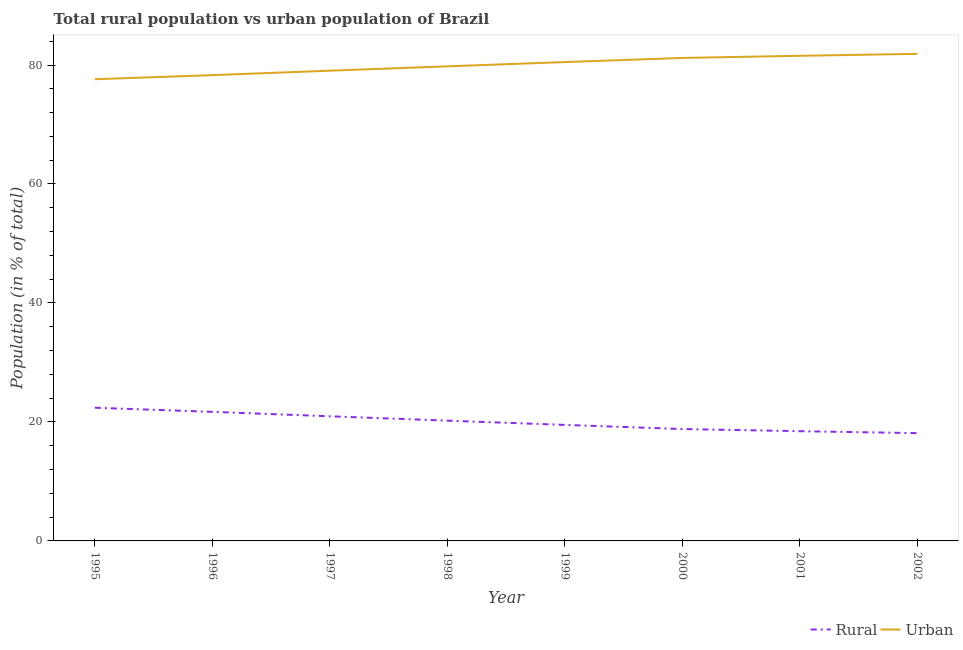What is the urban population in 1997?
Provide a short and direct response. 79.05. Across all years, what is the maximum urban population?
Make the answer very short. 81.88. Across all years, what is the minimum urban population?
Provide a short and direct response. 77.61. In which year was the rural population maximum?
Ensure brevity in your answer.  1995. What is the total rural population in the graph?
Keep it short and to the point. 160.14. What is the difference between the urban population in 1998 and that in 1999?
Your answer should be very brief. -0.72. What is the difference between the urban population in 1997 and the rural population in 1995?
Your response must be concise. 56.66. What is the average rural population per year?
Your response must be concise. 20.02. In the year 1995, what is the difference between the urban population and rural population?
Provide a short and direct response. 55.22. In how many years, is the rural population greater than 4 %?
Ensure brevity in your answer.  8. What is the ratio of the rural population in 1999 to that in 2002?
Your answer should be compact. 1.08. What is the difference between the highest and the second highest urban population?
Provide a short and direct response. 0.33. What is the difference between the highest and the lowest urban population?
Give a very brief answer. 4.27. In how many years, is the rural population greater than the average rural population taken over all years?
Your answer should be compact. 4. Does the urban population monotonically increase over the years?
Provide a succinct answer. Yes. Is the urban population strictly greater than the rural population over the years?
Provide a succinct answer. Yes. What is the difference between two consecutive major ticks on the Y-axis?
Give a very brief answer. 20. Are the values on the major ticks of Y-axis written in scientific E-notation?
Provide a short and direct response. No. How many legend labels are there?
Offer a very short reply. 2. How are the legend labels stacked?
Offer a very short reply. Horizontal. What is the title of the graph?
Keep it short and to the point. Total rural population vs urban population of Brazil. What is the label or title of the Y-axis?
Keep it short and to the point. Population (in % of total). What is the Population (in % of total) of Rural in 1995?
Your response must be concise. 22.39. What is the Population (in % of total) of Urban in 1995?
Ensure brevity in your answer.  77.61. What is the Population (in % of total) of Rural in 1996?
Make the answer very short. 21.7. What is the Population (in % of total) in Urban in 1996?
Ensure brevity in your answer.  78.3. What is the Population (in % of total) of Rural in 1997?
Make the answer very short. 20.95. What is the Population (in % of total) in Urban in 1997?
Provide a succinct answer. 79.05. What is the Population (in % of total) of Rural in 1998?
Your response must be concise. 20.22. What is the Population (in % of total) of Urban in 1998?
Your answer should be compact. 79.78. What is the Population (in % of total) in Rural in 1999?
Your response must be concise. 19.5. What is the Population (in % of total) in Urban in 1999?
Keep it short and to the point. 80.5. What is the Population (in % of total) in Rural in 2000?
Keep it short and to the point. 18.81. What is the Population (in % of total) of Urban in 2000?
Provide a short and direct response. 81.19. What is the Population (in % of total) in Rural in 2001?
Your response must be concise. 18.45. What is the Population (in % of total) of Urban in 2001?
Keep it short and to the point. 81.55. What is the Population (in % of total) in Rural in 2002?
Provide a short and direct response. 18.12. What is the Population (in % of total) of Urban in 2002?
Give a very brief answer. 81.88. Across all years, what is the maximum Population (in % of total) in Rural?
Offer a terse response. 22.39. Across all years, what is the maximum Population (in % of total) in Urban?
Your answer should be very brief. 81.88. Across all years, what is the minimum Population (in % of total) in Rural?
Your answer should be very brief. 18.12. Across all years, what is the minimum Population (in % of total) of Urban?
Ensure brevity in your answer.  77.61. What is the total Population (in % of total) in Rural in the graph?
Provide a short and direct response. 160.14. What is the total Population (in % of total) in Urban in the graph?
Your response must be concise. 639.86. What is the difference between the Population (in % of total) of Rural in 1995 and that in 1996?
Ensure brevity in your answer.  0.69. What is the difference between the Population (in % of total) in Urban in 1995 and that in 1996?
Give a very brief answer. -0.69. What is the difference between the Population (in % of total) of Rural in 1995 and that in 1997?
Give a very brief answer. 1.44. What is the difference between the Population (in % of total) in Urban in 1995 and that in 1997?
Your answer should be very brief. -1.44. What is the difference between the Population (in % of total) of Rural in 1995 and that in 1998?
Provide a short and direct response. 2.17. What is the difference between the Population (in % of total) of Urban in 1995 and that in 1998?
Your answer should be compact. -2.17. What is the difference between the Population (in % of total) of Rural in 1995 and that in 1999?
Keep it short and to the point. 2.89. What is the difference between the Population (in % of total) in Urban in 1995 and that in 1999?
Make the answer very short. -2.89. What is the difference between the Population (in % of total) in Rural in 1995 and that in 2000?
Give a very brief answer. 3.58. What is the difference between the Population (in % of total) in Urban in 1995 and that in 2000?
Your answer should be compact. -3.58. What is the difference between the Population (in % of total) in Rural in 1995 and that in 2001?
Offer a terse response. 3.94. What is the difference between the Population (in % of total) of Urban in 1995 and that in 2001?
Offer a very short reply. -3.94. What is the difference between the Population (in % of total) of Rural in 1995 and that in 2002?
Provide a short and direct response. 4.27. What is the difference between the Population (in % of total) in Urban in 1995 and that in 2002?
Ensure brevity in your answer.  -4.27. What is the difference between the Population (in % of total) in Rural in 1996 and that in 1997?
Make the answer very short. 0.75. What is the difference between the Population (in % of total) in Urban in 1996 and that in 1997?
Your response must be concise. -0.75. What is the difference between the Population (in % of total) of Rural in 1996 and that in 1998?
Offer a very short reply. 1.48. What is the difference between the Population (in % of total) in Urban in 1996 and that in 1998?
Offer a very short reply. -1.48. What is the difference between the Population (in % of total) in Rural in 1996 and that in 1999?
Your answer should be compact. 2.19. What is the difference between the Population (in % of total) of Urban in 1996 and that in 1999?
Offer a terse response. -2.19. What is the difference between the Population (in % of total) of Rural in 1996 and that in 2000?
Your response must be concise. 2.89. What is the difference between the Population (in % of total) in Urban in 1996 and that in 2000?
Your answer should be very brief. -2.89. What is the difference between the Population (in % of total) of Rural in 1996 and that in 2001?
Your answer should be very brief. 3.25. What is the difference between the Population (in % of total) of Urban in 1996 and that in 2001?
Your response must be concise. -3.25. What is the difference between the Population (in % of total) in Rural in 1996 and that in 2002?
Keep it short and to the point. 3.58. What is the difference between the Population (in % of total) of Urban in 1996 and that in 2002?
Provide a succinct answer. -3.58. What is the difference between the Population (in % of total) in Rural in 1997 and that in 1998?
Provide a succinct answer. 0.73. What is the difference between the Population (in % of total) of Urban in 1997 and that in 1998?
Give a very brief answer. -0.73. What is the difference between the Population (in % of total) in Rural in 1997 and that in 1999?
Make the answer very short. 1.45. What is the difference between the Population (in % of total) of Urban in 1997 and that in 1999?
Your response must be concise. -1.45. What is the difference between the Population (in % of total) of Rural in 1997 and that in 2000?
Your answer should be very brief. 2.14. What is the difference between the Population (in % of total) in Urban in 1997 and that in 2000?
Keep it short and to the point. -2.14. What is the difference between the Population (in % of total) of Rural in 1997 and that in 2001?
Offer a very short reply. 2.5. What is the difference between the Population (in % of total) of Urban in 1997 and that in 2001?
Your answer should be compact. -2.5. What is the difference between the Population (in % of total) of Rural in 1997 and that in 2002?
Your answer should be very brief. 2.83. What is the difference between the Population (in % of total) in Urban in 1997 and that in 2002?
Your answer should be very brief. -2.83. What is the difference between the Population (in % of total) of Rural in 1998 and that in 1999?
Your response must be concise. 0.71. What is the difference between the Population (in % of total) of Urban in 1998 and that in 1999?
Keep it short and to the point. -0.71. What is the difference between the Population (in % of total) of Rural in 1998 and that in 2000?
Ensure brevity in your answer.  1.41. What is the difference between the Population (in % of total) in Urban in 1998 and that in 2000?
Give a very brief answer. -1.41. What is the difference between the Population (in % of total) in Rural in 1998 and that in 2001?
Provide a succinct answer. 1.77. What is the difference between the Population (in % of total) in Urban in 1998 and that in 2001?
Give a very brief answer. -1.77. What is the difference between the Population (in % of total) in Rural in 1998 and that in 2002?
Provide a succinct answer. 2.1. What is the difference between the Population (in % of total) in Urban in 1998 and that in 2002?
Make the answer very short. -2.1. What is the difference between the Population (in % of total) of Rural in 1999 and that in 2000?
Your answer should be very brief. 0.7. What is the difference between the Population (in % of total) in Urban in 1999 and that in 2000?
Your response must be concise. -0.7. What is the difference between the Population (in % of total) of Rural in 1999 and that in 2001?
Offer a very short reply. 1.06. What is the difference between the Population (in % of total) in Urban in 1999 and that in 2001?
Make the answer very short. -1.06. What is the difference between the Population (in % of total) of Rural in 1999 and that in 2002?
Provide a short and direct response. 1.38. What is the difference between the Population (in % of total) of Urban in 1999 and that in 2002?
Your response must be concise. -1.38. What is the difference between the Population (in % of total) of Rural in 2000 and that in 2001?
Keep it short and to the point. 0.36. What is the difference between the Population (in % of total) in Urban in 2000 and that in 2001?
Keep it short and to the point. -0.36. What is the difference between the Population (in % of total) of Rural in 2000 and that in 2002?
Offer a very short reply. 0.69. What is the difference between the Population (in % of total) of Urban in 2000 and that in 2002?
Offer a very short reply. -0.69. What is the difference between the Population (in % of total) in Rural in 2001 and that in 2002?
Make the answer very short. 0.33. What is the difference between the Population (in % of total) of Urban in 2001 and that in 2002?
Provide a succinct answer. -0.33. What is the difference between the Population (in % of total) in Rural in 1995 and the Population (in % of total) in Urban in 1996?
Offer a very short reply. -55.91. What is the difference between the Population (in % of total) of Rural in 1995 and the Population (in % of total) of Urban in 1997?
Your answer should be very brief. -56.66. What is the difference between the Population (in % of total) in Rural in 1995 and the Population (in % of total) in Urban in 1998?
Keep it short and to the point. -57.39. What is the difference between the Population (in % of total) in Rural in 1995 and the Population (in % of total) in Urban in 1999?
Make the answer very short. -58.11. What is the difference between the Population (in % of total) of Rural in 1995 and the Population (in % of total) of Urban in 2000?
Provide a short and direct response. -58.8. What is the difference between the Population (in % of total) in Rural in 1995 and the Population (in % of total) in Urban in 2001?
Offer a very short reply. -59.16. What is the difference between the Population (in % of total) in Rural in 1995 and the Population (in % of total) in Urban in 2002?
Your answer should be compact. -59.49. What is the difference between the Population (in % of total) in Rural in 1996 and the Population (in % of total) in Urban in 1997?
Offer a terse response. -57.35. What is the difference between the Population (in % of total) in Rural in 1996 and the Population (in % of total) in Urban in 1998?
Your response must be concise. -58.08. What is the difference between the Population (in % of total) of Rural in 1996 and the Population (in % of total) of Urban in 1999?
Offer a terse response. -58.8. What is the difference between the Population (in % of total) of Rural in 1996 and the Population (in % of total) of Urban in 2000?
Ensure brevity in your answer.  -59.49. What is the difference between the Population (in % of total) in Rural in 1996 and the Population (in % of total) in Urban in 2001?
Make the answer very short. -59.85. What is the difference between the Population (in % of total) of Rural in 1996 and the Population (in % of total) of Urban in 2002?
Provide a short and direct response. -60.18. What is the difference between the Population (in % of total) in Rural in 1997 and the Population (in % of total) in Urban in 1998?
Keep it short and to the point. -58.83. What is the difference between the Population (in % of total) in Rural in 1997 and the Population (in % of total) in Urban in 1999?
Give a very brief answer. -59.54. What is the difference between the Population (in % of total) of Rural in 1997 and the Population (in % of total) of Urban in 2000?
Keep it short and to the point. -60.24. What is the difference between the Population (in % of total) in Rural in 1997 and the Population (in % of total) in Urban in 2001?
Your answer should be compact. -60.6. What is the difference between the Population (in % of total) in Rural in 1997 and the Population (in % of total) in Urban in 2002?
Give a very brief answer. -60.93. What is the difference between the Population (in % of total) in Rural in 1998 and the Population (in % of total) in Urban in 1999?
Your response must be concise. -60.28. What is the difference between the Population (in % of total) in Rural in 1998 and the Population (in % of total) in Urban in 2000?
Your response must be concise. -60.97. What is the difference between the Population (in % of total) of Rural in 1998 and the Population (in % of total) of Urban in 2001?
Provide a succinct answer. -61.33. What is the difference between the Population (in % of total) of Rural in 1998 and the Population (in % of total) of Urban in 2002?
Your response must be concise. -61.66. What is the difference between the Population (in % of total) of Rural in 1999 and the Population (in % of total) of Urban in 2000?
Your response must be concise. -61.69. What is the difference between the Population (in % of total) of Rural in 1999 and the Population (in % of total) of Urban in 2001?
Offer a very short reply. -62.05. What is the difference between the Population (in % of total) in Rural in 1999 and the Population (in % of total) in Urban in 2002?
Keep it short and to the point. -62.38. What is the difference between the Population (in % of total) in Rural in 2000 and the Population (in % of total) in Urban in 2001?
Keep it short and to the point. -62.74. What is the difference between the Population (in % of total) in Rural in 2000 and the Population (in % of total) in Urban in 2002?
Your response must be concise. -63.07. What is the difference between the Population (in % of total) of Rural in 2001 and the Population (in % of total) of Urban in 2002?
Provide a short and direct response. -63.43. What is the average Population (in % of total) in Rural per year?
Provide a succinct answer. 20.02. What is the average Population (in % of total) in Urban per year?
Give a very brief answer. 79.98. In the year 1995, what is the difference between the Population (in % of total) of Rural and Population (in % of total) of Urban?
Your answer should be very brief. -55.22. In the year 1996, what is the difference between the Population (in % of total) of Rural and Population (in % of total) of Urban?
Provide a succinct answer. -56.6. In the year 1997, what is the difference between the Population (in % of total) in Rural and Population (in % of total) in Urban?
Your response must be concise. -58.1. In the year 1998, what is the difference between the Population (in % of total) of Rural and Population (in % of total) of Urban?
Your answer should be very brief. -59.56. In the year 1999, what is the difference between the Population (in % of total) in Rural and Population (in % of total) in Urban?
Offer a terse response. -60.99. In the year 2000, what is the difference between the Population (in % of total) in Rural and Population (in % of total) in Urban?
Provide a short and direct response. -62.38. In the year 2001, what is the difference between the Population (in % of total) in Rural and Population (in % of total) in Urban?
Your answer should be compact. -63.11. In the year 2002, what is the difference between the Population (in % of total) of Rural and Population (in % of total) of Urban?
Offer a terse response. -63.76. What is the ratio of the Population (in % of total) of Rural in 1995 to that in 1996?
Your answer should be compact. 1.03. What is the ratio of the Population (in % of total) in Rural in 1995 to that in 1997?
Your answer should be compact. 1.07. What is the ratio of the Population (in % of total) of Urban in 1995 to that in 1997?
Offer a terse response. 0.98. What is the ratio of the Population (in % of total) of Rural in 1995 to that in 1998?
Provide a short and direct response. 1.11. What is the ratio of the Population (in % of total) in Urban in 1995 to that in 1998?
Offer a very short reply. 0.97. What is the ratio of the Population (in % of total) in Rural in 1995 to that in 1999?
Offer a very short reply. 1.15. What is the ratio of the Population (in % of total) in Urban in 1995 to that in 1999?
Keep it short and to the point. 0.96. What is the ratio of the Population (in % of total) in Rural in 1995 to that in 2000?
Provide a short and direct response. 1.19. What is the ratio of the Population (in % of total) in Urban in 1995 to that in 2000?
Your answer should be compact. 0.96. What is the ratio of the Population (in % of total) of Rural in 1995 to that in 2001?
Your answer should be very brief. 1.21. What is the ratio of the Population (in % of total) of Urban in 1995 to that in 2001?
Ensure brevity in your answer.  0.95. What is the ratio of the Population (in % of total) in Rural in 1995 to that in 2002?
Provide a short and direct response. 1.24. What is the ratio of the Population (in % of total) of Urban in 1995 to that in 2002?
Offer a terse response. 0.95. What is the ratio of the Population (in % of total) of Rural in 1996 to that in 1997?
Offer a terse response. 1.04. What is the ratio of the Population (in % of total) in Urban in 1996 to that in 1997?
Ensure brevity in your answer.  0.99. What is the ratio of the Population (in % of total) in Rural in 1996 to that in 1998?
Keep it short and to the point. 1.07. What is the ratio of the Population (in % of total) in Urban in 1996 to that in 1998?
Your answer should be compact. 0.98. What is the ratio of the Population (in % of total) of Rural in 1996 to that in 1999?
Give a very brief answer. 1.11. What is the ratio of the Population (in % of total) of Urban in 1996 to that in 1999?
Offer a terse response. 0.97. What is the ratio of the Population (in % of total) of Rural in 1996 to that in 2000?
Provide a succinct answer. 1.15. What is the ratio of the Population (in % of total) of Urban in 1996 to that in 2000?
Your answer should be compact. 0.96. What is the ratio of the Population (in % of total) of Rural in 1996 to that in 2001?
Keep it short and to the point. 1.18. What is the ratio of the Population (in % of total) of Urban in 1996 to that in 2001?
Make the answer very short. 0.96. What is the ratio of the Population (in % of total) in Rural in 1996 to that in 2002?
Offer a terse response. 1.2. What is the ratio of the Population (in % of total) of Urban in 1996 to that in 2002?
Ensure brevity in your answer.  0.96. What is the ratio of the Population (in % of total) of Rural in 1997 to that in 1998?
Keep it short and to the point. 1.04. What is the ratio of the Population (in % of total) of Rural in 1997 to that in 1999?
Make the answer very short. 1.07. What is the ratio of the Population (in % of total) of Rural in 1997 to that in 2000?
Offer a terse response. 1.11. What is the ratio of the Population (in % of total) in Urban in 1997 to that in 2000?
Make the answer very short. 0.97. What is the ratio of the Population (in % of total) in Rural in 1997 to that in 2001?
Offer a very short reply. 1.14. What is the ratio of the Population (in % of total) of Urban in 1997 to that in 2001?
Ensure brevity in your answer.  0.97. What is the ratio of the Population (in % of total) of Rural in 1997 to that in 2002?
Your answer should be very brief. 1.16. What is the ratio of the Population (in % of total) of Urban in 1997 to that in 2002?
Your answer should be very brief. 0.97. What is the ratio of the Population (in % of total) in Rural in 1998 to that in 1999?
Offer a very short reply. 1.04. What is the ratio of the Population (in % of total) of Urban in 1998 to that in 1999?
Make the answer very short. 0.99. What is the ratio of the Population (in % of total) in Rural in 1998 to that in 2000?
Offer a terse response. 1.07. What is the ratio of the Population (in % of total) of Urban in 1998 to that in 2000?
Keep it short and to the point. 0.98. What is the ratio of the Population (in % of total) of Rural in 1998 to that in 2001?
Provide a succinct answer. 1.1. What is the ratio of the Population (in % of total) of Urban in 1998 to that in 2001?
Offer a very short reply. 0.98. What is the ratio of the Population (in % of total) of Rural in 1998 to that in 2002?
Your response must be concise. 1.12. What is the ratio of the Population (in % of total) of Urban in 1998 to that in 2002?
Your answer should be very brief. 0.97. What is the ratio of the Population (in % of total) of Urban in 1999 to that in 2000?
Ensure brevity in your answer.  0.99. What is the ratio of the Population (in % of total) in Rural in 1999 to that in 2001?
Ensure brevity in your answer.  1.06. What is the ratio of the Population (in % of total) in Rural in 1999 to that in 2002?
Keep it short and to the point. 1.08. What is the ratio of the Population (in % of total) of Urban in 1999 to that in 2002?
Your answer should be very brief. 0.98. What is the ratio of the Population (in % of total) in Rural in 2000 to that in 2001?
Give a very brief answer. 1.02. What is the ratio of the Population (in % of total) in Urban in 2000 to that in 2001?
Offer a very short reply. 1. What is the ratio of the Population (in % of total) of Rural in 2000 to that in 2002?
Keep it short and to the point. 1.04. What is the ratio of the Population (in % of total) of Urban in 2000 to that in 2002?
Offer a terse response. 0.99. What is the ratio of the Population (in % of total) of Rural in 2001 to that in 2002?
Ensure brevity in your answer.  1.02. What is the difference between the highest and the second highest Population (in % of total) in Rural?
Keep it short and to the point. 0.69. What is the difference between the highest and the second highest Population (in % of total) in Urban?
Offer a very short reply. 0.33. What is the difference between the highest and the lowest Population (in % of total) of Rural?
Provide a succinct answer. 4.27. What is the difference between the highest and the lowest Population (in % of total) in Urban?
Your answer should be compact. 4.27. 